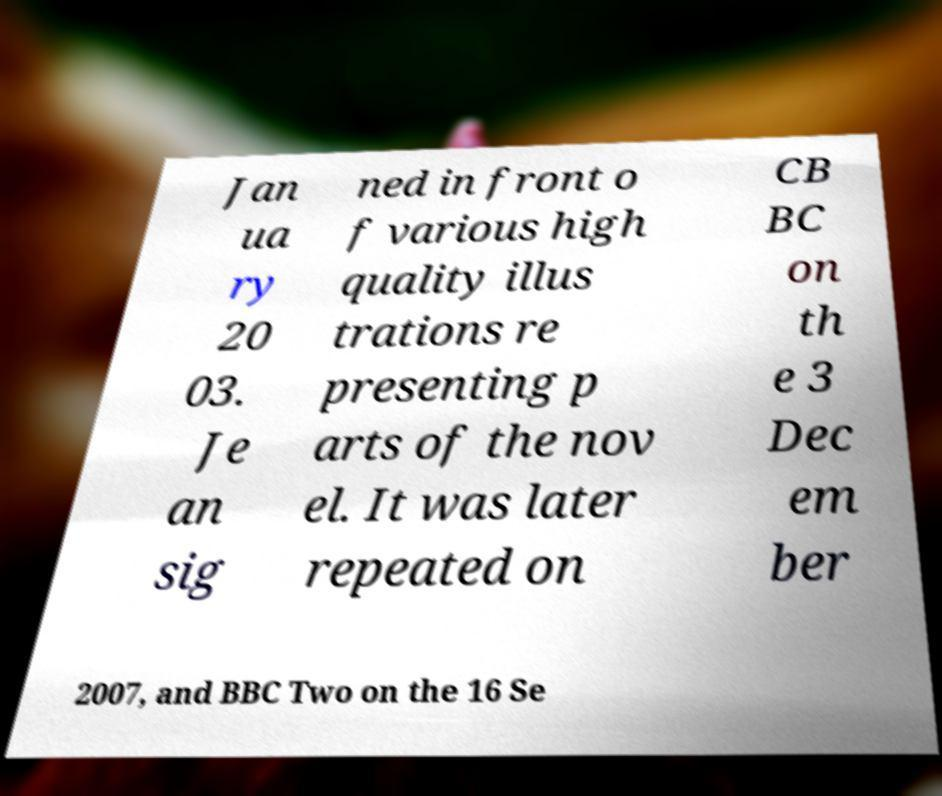What messages or text are displayed in this image? I need them in a readable, typed format. Jan ua ry 20 03. Je an sig ned in front o f various high quality illus trations re presenting p arts of the nov el. It was later repeated on CB BC on th e 3 Dec em ber 2007, and BBC Two on the 16 Se 